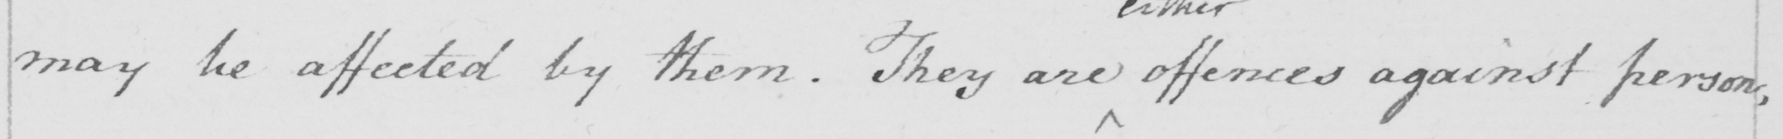Can you read and transcribe this handwriting? may be affected by them. They are offences against person, 